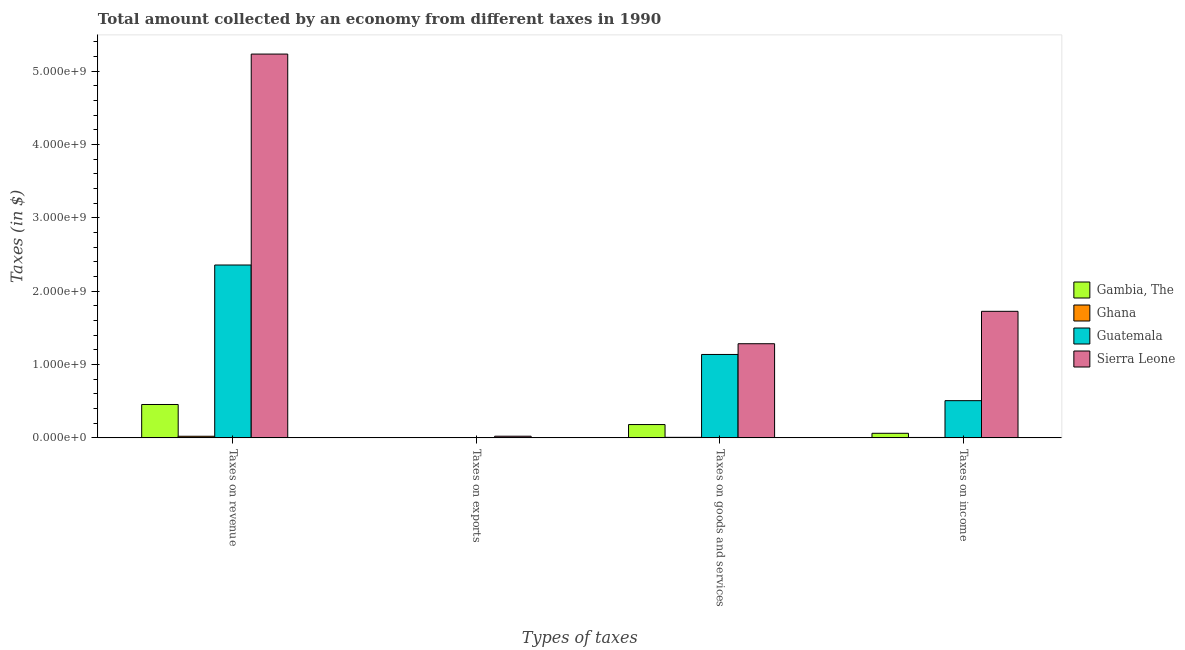How many different coloured bars are there?
Make the answer very short. 4. Are the number of bars per tick equal to the number of legend labels?
Your answer should be compact. Yes. How many bars are there on the 4th tick from the left?
Provide a succinct answer. 4. How many bars are there on the 1st tick from the right?
Offer a very short reply. 4. What is the label of the 3rd group of bars from the left?
Your answer should be very brief. Taxes on goods and services. What is the amount collected as tax on goods in Gambia, The?
Provide a succinct answer. 1.81e+08. Across all countries, what is the maximum amount collected as tax on revenue?
Provide a short and direct response. 5.23e+09. Across all countries, what is the minimum amount collected as tax on goods?
Offer a very short reply. 7.17e+06. In which country was the amount collected as tax on revenue maximum?
Offer a terse response. Sierra Leone. What is the total amount collected as tax on revenue in the graph?
Ensure brevity in your answer.  8.06e+09. What is the difference between the amount collected as tax on income in Sierra Leone and that in Guatemala?
Your response must be concise. 1.22e+09. What is the difference between the amount collected as tax on goods in Sierra Leone and the amount collected as tax on exports in Ghana?
Give a very brief answer. 1.28e+09. What is the average amount collected as tax on income per country?
Offer a terse response. 5.75e+08. What is the difference between the amount collected as tax on revenue and amount collected as tax on goods in Gambia, The?
Ensure brevity in your answer.  2.73e+08. What is the ratio of the amount collected as tax on goods in Sierra Leone to that in Ghana?
Keep it short and to the point. 178.92. Is the difference between the amount collected as tax on exports in Sierra Leone and Gambia, The greater than the difference between the amount collected as tax on goods in Sierra Leone and Gambia, The?
Provide a short and direct response. No. What is the difference between the highest and the second highest amount collected as tax on revenue?
Provide a succinct answer. 2.88e+09. What is the difference between the highest and the lowest amount collected as tax on income?
Your answer should be very brief. 1.72e+09. In how many countries, is the amount collected as tax on revenue greater than the average amount collected as tax on revenue taken over all countries?
Ensure brevity in your answer.  2. What does the 4th bar from the left in Taxes on exports represents?
Give a very brief answer. Sierra Leone. What does the 4th bar from the right in Taxes on revenue represents?
Keep it short and to the point. Gambia, The. How many bars are there?
Your answer should be compact. 16. Does the graph contain grids?
Offer a terse response. No. Where does the legend appear in the graph?
Your response must be concise. Center right. How are the legend labels stacked?
Provide a short and direct response. Vertical. What is the title of the graph?
Offer a terse response. Total amount collected by an economy from different taxes in 1990. Does "Azerbaijan" appear as one of the legend labels in the graph?
Provide a succinct answer. No. What is the label or title of the X-axis?
Give a very brief answer. Types of taxes. What is the label or title of the Y-axis?
Offer a terse response. Taxes (in $). What is the Taxes (in $) in Gambia, The in Taxes on revenue?
Your response must be concise. 4.55e+08. What is the Taxes (in $) of Ghana in Taxes on revenue?
Provide a succinct answer. 2.20e+07. What is the Taxes (in $) of Guatemala in Taxes on revenue?
Make the answer very short. 2.36e+09. What is the Taxes (in $) of Sierra Leone in Taxes on revenue?
Your response must be concise. 5.23e+09. What is the Taxes (in $) of Gambia, The in Taxes on exports?
Offer a very short reply. 9.00e+05. What is the Taxes (in $) in Ghana in Taxes on exports?
Offer a very short reply. 2.72e+06. What is the Taxes (in $) of Guatemala in Taxes on exports?
Offer a terse response. 4.63e+06. What is the Taxes (in $) in Sierra Leone in Taxes on exports?
Your answer should be very brief. 2.27e+07. What is the Taxes (in $) in Gambia, The in Taxes on goods and services?
Make the answer very short. 1.81e+08. What is the Taxes (in $) in Ghana in Taxes on goods and services?
Ensure brevity in your answer.  7.17e+06. What is the Taxes (in $) in Guatemala in Taxes on goods and services?
Make the answer very short. 1.14e+09. What is the Taxes (in $) in Sierra Leone in Taxes on goods and services?
Provide a short and direct response. 1.28e+09. What is the Taxes (in $) of Gambia, The in Taxes on income?
Provide a short and direct response. 6.24e+07. What is the Taxes (in $) in Ghana in Taxes on income?
Make the answer very short. 5.51e+06. What is the Taxes (in $) of Guatemala in Taxes on income?
Offer a terse response. 5.07e+08. What is the Taxes (in $) in Sierra Leone in Taxes on income?
Provide a succinct answer. 1.72e+09. Across all Types of taxes, what is the maximum Taxes (in $) in Gambia, The?
Your response must be concise. 4.55e+08. Across all Types of taxes, what is the maximum Taxes (in $) in Ghana?
Your response must be concise. 2.20e+07. Across all Types of taxes, what is the maximum Taxes (in $) in Guatemala?
Your response must be concise. 2.36e+09. Across all Types of taxes, what is the maximum Taxes (in $) of Sierra Leone?
Ensure brevity in your answer.  5.23e+09. Across all Types of taxes, what is the minimum Taxes (in $) in Gambia, The?
Keep it short and to the point. 9.00e+05. Across all Types of taxes, what is the minimum Taxes (in $) of Ghana?
Offer a very short reply. 2.72e+06. Across all Types of taxes, what is the minimum Taxes (in $) of Guatemala?
Provide a short and direct response. 4.63e+06. Across all Types of taxes, what is the minimum Taxes (in $) in Sierra Leone?
Make the answer very short. 2.27e+07. What is the total Taxes (in $) in Gambia, The in the graph?
Your answer should be very brief. 7.00e+08. What is the total Taxes (in $) in Ghana in the graph?
Offer a very short reply. 3.74e+07. What is the total Taxes (in $) in Guatemala in the graph?
Give a very brief answer. 4.00e+09. What is the total Taxes (in $) in Sierra Leone in the graph?
Your answer should be very brief. 8.26e+09. What is the difference between the Taxes (in $) in Gambia, The in Taxes on revenue and that in Taxes on exports?
Offer a very short reply. 4.54e+08. What is the difference between the Taxes (in $) in Ghana in Taxes on revenue and that in Taxes on exports?
Provide a short and direct response. 1.92e+07. What is the difference between the Taxes (in $) of Guatemala in Taxes on revenue and that in Taxes on exports?
Ensure brevity in your answer.  2.35e+09. What is the difference between the Taxes (in $) in Sierra Leone in Taxes on revenue and that in Taxes on exports?
Your answer should be very brief. 5.21e+09. What is the difference between the Taxes (in $) in Gambia, The in Taxes on revenue and that in Taxes on goods and services?
Your answer should be compact. 2.73e+08. What is the difference between the Taxes (in $) in Ghana in Taxes on revenue and that in Taxes on goods and services?
Give a very brief answer. 1.48e+07. What is the difference between the Taxes (in $) in Guatemala in Taxes on revenue and that in Taxes on goods and services?
Your answer should be compact. 1.22e+09. What is the difference between the Taxes (in $) of Sierra Leone in Taxes on revenue and that in Taxes on goods and services?
Offer a very short reply. 3.95e+09. What is the difference between the Taxes (in $) of Gambia, The in Taxes on revenue and that in Taxes on income?
Your response must be concise. 3.92e+08. What is the difference between the Taxes (in $) in Ghana in Taxes on revenue and that in Taxes on income?
Offer a terse response. 1.65e+07. What is the difference between the Taxes (in $) in Guatemala in Taxes on revenue and that in Taxes on income?
Your answer should be compact. 1.85e+09. What is the difference between the Taxes (in $) in Sierra Leone in Taxes on revenue and that in Taxes on income?
Ensure brevity in your answer.  3.51e+09. What is the difference between the Taxes (in $) in Gambia, The in Taxes on exports and that in Taxes on goods and services?
Provide a short and direct response. -1.81e+08. What is the difference between the Taxes (in $) of Ghana in Taxes on exports and that in Taxes on goods and services?
Make the answer very short. -4.45e+06. What is the difference between the Taxes (in $) of Guatemala in Taxes on exports and that in Taxes on goods and services?
Provide a short and direct response. -1.13e+09. What is the difference between the Taxes (in $) in Sierra Leone in Taxes on exports and that in Taxes on goods and services?
Ensure brevity in your answer.  -1.26e+09. What is the difference between the Taxes (in $) in Gambia, The in Taxes on exports and that in Taxes on income?
Ensure brevity in your answer.  -6.15e+07. What is the difference between the Taxes (in $) of Ghana in Taxes on exports and that in Taxes on income?
Provide a succinct answer. -2.80e+06. What is the difference between the Taxes (in $) of Guatemala in Taxes on exports and that in Taxes on income?
Keep it short and to the point. -5.02e+08. What is the difference between the Taxes (in $) in Sierra Leone in Taxes on exports and that in Taxes on income?
Ensure brevity in your answer.  -1.70e+09. What is the difference between the Taxes (in $) in Gambia, The in Taxes on goods and services and that in Taxes on income?
Make the answer very short. 1.19e+08. What is the difference between the Taxes (in $) in Ghana in Taxes on goods and services and that in Taxes on income?
Keep it short and to the point. 1.66e+06. What is the difference between the Taxes (in $) of Guatemala in Taxes on goods and services and that in Taxes on income?
Ensure brevity in your answer.  6.30e+08. What is the difference between the Taxes (in $) of Sierra Leone in Taxes on goods and services and that in Taxes on income?
Offer a terse response. -4.42e+08. What is the difference between the Taxes (in $) in Gambia, The in Taxes on revenue and the Taxes (in $) in Ghana in Taxes on exports?
Your answer should be compact. 4.52e+08. What is the difference between the Taxes (in $) of Gambia, The in Taxes on revenue and the Taxes (in $) of Guatemala in Taxes on exports?
Keep it short and to the point. 4.50e+08. What is the difference between the Taxes (in $) in Gambia, The in Taxes on revenue and the Taxes (in $) in Sierra Leone in Taxes on exports?
Keep it short and to the point. 4.32e+08. What is the difference between the Taxes (in $) of Ghana in Taxes on revenue and the Taxes (in $) of Guatemala in Taxes on exports?
Provide a succinct answer. 1.73e+07. What is the difference between the Taxes (in $) in Ghana in Taxes on revenue and the Taxes (in $) in Sierra Leone in Taxes on exports?
Your answer should be compact. -7.32e+05. What is the difference between the Taxes (in $) of Guatemala in Taxes on revenue and the Taxes (in $) of Sierra Leone in Taxes on exports?
Provide a succinct answer. 2.33e+09. What is the difference between the Taxes (in $) in Gambia, The in Taxes on revenue and the Taxes (in $) in Ghana in Taxes on goods and services?
Your answer should be very brief. 4.48e+08. What is the difference between the Taxes (in $) in Gambia, The in Taxes on revenue and the Taxes (in $) in Guatemala in Taxes on goods and services?
Your answer should be very brief. -6.82e+08. What is the difference between the Taxes (in $) of Gambia, The in Taxes on revenue and the Taxes (in $) of Sierra Leone in Taxes on goods and services?
Offer a very short reply. -8.28e+08. What is the difference between the Taxes (in $) of Ghana in Taxes on revenue and the Taxes (in $) of Guatemala in Taxes on goods and services?
Give a very brief answer. -1.11e+09. What is the difference between the Taxes (in $) in Ghana in Taxes on revenue and the Taxes (in $) in Sierra Leone in Taxes on goods and services?
Give a very brief answer. -1.26e+09. What is the difference between the Taxes (in $) in Guatemala in Taxes on revenue and the Taxes (in $) in Sierra Leone in Taxes on goods and services?
Your response must be concise. 1.07e+09. What is the difference between the Taxes (in $) in Gambia, The in Taxes on revenue and the Taxes (in $) in Ghana in Taxes on income?
Give a very brief answer. 4.49e+08. What is the difference between the Taxes (in $) of Gambia, The in Taxes on revenue and the Taxes (in $) of Guatemala in Taxes on income?
Your response must be concise. -5.22e+07. What is the difference between the Taxes (in $) of Gambia, The in Taxes on revenue and the Taxes (in $) of Sierra Leone in Taxes on income?
Give a very brief answer. -1.27e+09. What is the difference between the Taxes (in $) in Ghana in Taxes on revenue and the Taxes (in $) in Guatemala in Taxes on income?
Your answer should be compact. -4.85e+08. What is the difference between the Taxes (in $) in Ghana in Taxes on revenue and the Taxes (in $) in Sierra Leone in Taxes on income?
Give a very brief answer. -1.70e+09. What is the difference between the Taxes (in $) in Guatemala in Taxes on revenue and the Taxes (in $) in Sierra Leone in Taxes on income?
Keep it short and to the point. 6.31e+08. What is the difference between the Taxes (in $) in Gambia, The in Taxes on exports and the Taxes (in $) in Ghana in Taxes on goods and services?
Your answer should be very brief. -6.27e+06. What is the difference between the Taxes (in $) in Gambia, The in Taxes on exports and the Taxes (in $) in Guatemala in Taxes on goods and services?
Provide a short and direct response. -1.14e+09. What is the difference between the Taxes (in $) in Gambia, The in Taxes on exports and the Taxes (in $) in Sierra Leone in Taxes on goods and services?
Offer a terse response. -1.28e+09. What is the difference between the Taxes (in $) in Ghana in Taxes on exports and the Taxes (in $) in Guatemala in Taxes on goods and services?
Provide a succinct answer. -1.13e+09. What is the difference between the Taxes (in $) of Ghana in Taxes on exports and the Taxes (in $) of Sierra Leone in Taxes on goods and services?
Offer a terse response. -1.28e+09. What is the difference between the Taxes (in $) in Guatemala in Taxes on exports and the Taxes (in $) in Sierra Leone in Taxes on goods and services?
Give a very brief answer. -1.28e+09. What is the difference between the Taxes (in $) in Gambia, The in Taxes on exports and the Taxes (in $) in Ghana in Taxes on income?
Keep it short and to the point. -4.61e+06. What is the difference between the Taxes (in $) of Gambia, The in Taxes on exports and the Taxes (in $) of Guatemala in Taxes on income?
Provide a short and direct response. -5.06e+08. What is the difference between the Taxes (in $) of Gambia, The in Taxes on exports and the Taxes (in $) of Sierra Leone in Taxes on income?
Offer a terse response. -1.72e+09. What is the difference between the Taxes (in $) in Ghana in Taxes on exports and the Taxes (in $) in Guatemala in Taxes on income?
Make the answer very short. -5.04e+08. What is the difference between the Taxes (in $) in Ghana in Taxes on exports and the Taxes (in $) in Sierra Leone in Taxes on income?
Your response must be concise. -1.72e+09. What is the difference between the Taxes (in $) in Guatemala in Taxes on exports and the Taxes (in $) in Sierra Leone in Taxes on income?
Make the answer very short. -1.72e+09. What is the difference between the Taxes (in $) in Gambia, The in Taxes on goods and services and the Taxes (in $) in Ghana in Taxes on income?
Keep it short and to the point. 1.76e+08. What is the difference between the Taxes (in $) in Gambia, The in Taxes on goods and services and the Taxes (in $) in Guatemala in Taxes on income?
Offer a terse response. -3.26e+08. What is the difference between the Taxes (in $) of Gambia, The in Taxes on goods and services and the Taxes (in $) of Sierra Leone in Taxes on income?
Give a very brief answer. -1.54e+09. What is the difference between the Taxes (in $) in Ghana in Taxes on goods and services and the Taxes (in $) in Guatemala in Taxes on income?
Your answer should be very brief. -5.00e+08. What is the difference between the Taxes (in $) in Ghana in Taxes on goods and services and the Taxes (in $) in Sierra Leone in Taxes on income?
Offer a very short reply. -1.72e+09. What is the difference between the Taxes (in $) in Guatemala in Taxes on goods and services and the Taxes (in $) in Sierra Leone in Taxes on income?
Provide a short and direct response. -5.88e+08. What is the average Taxes (in $) of Gambia, The per Types of taxes?
Your answer should be compact. 1.75e+08. What is the average Taxes (in $) of Ghana per Types of taxes?
Keep it short and to the point. 9.34e+06. What is the average Taxes (in $) of Guatemala per Types of taxes?
Provide a short and direct response. 1.00e+09. What is the average Taxes (in $) in Sierra Leone per Types of taxes?
Make the answer very short. 2.07e+09. What is the difference between the Taxes (in $) of Gambia, The and Taxes (in $) of Ghana in Taxes on revenue?
Your response must be concise. 4.33e+08. What is the difference between the Taxes (in $) in Gambia, The and Taxes (in $) in Guatemala in Taxes on revenue?
Offer a very short reply. -1.90e+09. What is the difference between the Taxes (in $) of Gambia, The and Taxes (in $) of Sierra Leone in Taxes on revenue?
Give a very brief answer. -4.78e+09. What is the difference between the Taxes (in $) of Ghana and Taxes (in $) of Guatemala in Taxes on revenue?
Your response must be concise. -2.33e+09. What is the difference between the Taxes (in $) of Ghana and Taxes (in $) of Sierra Leone in Taxes on revenue?
Keep it short and to the point. -5.21e+09. What is the difference between the Taxes (in $) in Guatemala and Taxes (in $) in Sierra Leone in Taxes on revenue?
Your response must be concise. -2.88e+09. What is the difference between the Taxes (in $) in Gambia, The and Taxes (in $) in Ghana in Taxes on exports?
Offer a terse response. -1.82e+06. What is the difference between the Taxes (in $) in Gambia, The and Taxes (in $) in Guatemala in Taxes on exports?
Give a very brief answer. -3.73e+06. What is the difference between the Taxes (in $) of Gambia, The and Taxes (in $) of Sierra Leone in Taxes on exports?
Ensure brevity in your answer.  -2.18e+07. What is the difference between the Taxes (in $) in Ghana and Taxes (in $) in Guatemala in Taxes on exports?
Keep it short and to the point. -1.91e+06. What is the difference between the Taxes (in $) of Ghana and Taxes (in $) of Sierra Leone in Taxes on exports?
Make the answer very short. -2.00e+07. What is the difference between the Taxes (in $) of Guatemala and Taxes (in $) of Sierra Leone in Taxes on exports?
Your answer should be compact. -1.81e+07. What is the difference between the Taxes (in $) in Gambia, The and Taxes (in $) in Ghana in Taxes on goods and services?
Your answer should be compact. 1.74e+08. What is the difference between the Taxes (in $) of Gambia, The and Taxes (in $) of Guatemala in Taxes on goods and services?
Your response must be concise. -9.55e+08. What is the difference between the Taxes (in $) of Gambia, The and Taxes (in $) of Sierra Leone in Taxes on goods and services?
Offer a very short reply. -1.10e+09. What is the difference between the Taxes (in $) of Ghana and Taxes (in $) of Guatemala in Taxes on goods and services?
Make the answer very short. -1.13e+09. What is the difference between the Taxes (in $) in Ghana and Taxes (in $) in Sierra Leone in Taxes on goods and services?
Make the answer very short. -1.28e+09. What is the difference between the Taxes (in $) of Guatemala and Taxes (in $) of Sierra Leone in Taxes on goods and services?
Offer a terse response. -1.46e+08. What is the difference between the Taxes (in $) in Gambia, The and Taxes (in $) in Ghana in Taxes on income?
Make the answer very short. 5.69e+07. What is the difference between the Taxes (in $) of Gambia, The and Taxes (in $) of Guatemala in Taxes on income?
Give a very brief answer. -4.45e+08. What is the difference between the Taxes (in $) in Gambia, The and Taxes (in $) in Sierra Leone in Taxes on income?
Give a very brief answer. -1.66e+09. What is the difference between the Taxes (in $) in Ghana and Taxes (in $) in Guatemala in Taxes on income?
Your answer should be very brief. -5.01e+08. What is the difference between the Taxes (in $) of Ghana and Taxes (in $) of Sierra Leone in Taxes on income?
Your answer should be very brief. -1.72e+09. What is the difference between the Taxes (in $) of Guatemala and Taxes (in $) of Sierra Leone in Taxes on income?
Ensure brevity in your answer.  -1.22e+09. What is the ratio of the Taxes (in $) in Gambia, The in Taxes on revenue to that in Taxes on exports?
Your answer should be very brief. 505.34. What is the ratio of the Taxes (in $) of Ghana in Taxes on revenue to that in Taxes on exports?
Provide a succinct answer. 8.08. What is the ratio of the Taxes (in $) in Guatemala in Taxes on revenue to that in Taxes on exports?
Make the answer very short. 508.84. What is the ratio of the Taxes (in $) in Sierra Leone in Taxes on revenue to that in Taxes on exports?
Your answer should be compact. 230.44. What is the ratio of the Taxes (in $) of Gambia, The in Taxes on revenue to that in Taxes on goods and services?
Ensure brevity in your answer.  2.51. What is the ratio of the Taxes (in $) in Ghana in Taxes on revenue to that in Taxes on goods and services?
Your answer should be very brief. 3.06. What is the ratio of the Taxes (in $) of Guatemala in Taxes on revenue to that in Taxes on goods and services?
Ensure brevity in your answer.  2.07. What is the ratio of the Taxes (in $) in Sierra Leone in Taxes on revenue to that in Taxes on goods and services?
Your answer should be compact. 4.08. What is the ratio of the Taxes (in $) of Gambia, The in Taxes on revenue to that in Taxes on income?
Offer a very short reply. 7.29. What is the ratio of the Taxes (in $) of Ghana in Taxes on revenue to that in Taxes on income?
Your answer should be very brief. 3.98. What is the ratio of the Taxes (in $) of Guatemala in Taxes on revenue to that in Taxes on income?
Your answer should be compact. 4.65. What is the ratio of the Taxes (in $) of Sierra Leone in Taxes on revenue to that in Taxes on income?
Keep it short and to the point. 3.03. What is the ratio of the Taxes (in $) of Gambia, The in Taxes on exports to that in Taxes on goods and services?
Provide a succinct answer. 0.01. What is the ratio of the Taxes (in $) of Ghana in Taxes on exports to that in Taxes on goods and services?
Your answer should be very brief. 0.38. What is the ratio of the Taxes (in $) of Guatemala in Taxes on exports to that in Taxes on goods and services?
Your answer should be very brief. 0. What is the ratio of the Taxes (in $) of Sierra Leone in Taxes on exports to that in Taxes on goods and services?
Your answer should be very brief. 0.02. What is the ratio of the Taxes (in $) in Gambia, The in Taxes on exports to that in Taxes on income?
Keep it short and to the point. 0.01. What is the ratio of the Taxes (in $) of Ghana in Taxes on exports to that in Taxes on income?
Your response must be concise. 0.49. What is the ratio of the Taxes (in $) of Guatemala in Taxes on exports to that in Taxes on income?
Offer a terse response. 0.01. What is the ratio of the Taxes (in $) in Sierra Leone in Taxes on exports to that in Taxes on income?
Make the answer very short. 0.01. What is the ratio of the Taxes (in $) of Gambia, The in Taxes on goods and services to that in Taxes on income?
Your answer should be compact. 2.91. What is the ratio of the Taxes (in $) in Ghana in Taxes on goods and services to that in Taxes on income?
Ensure brevity in your answer.  1.3. What is the ratio of the Taxes (in $) in Guatemala in Taxes on goods and services to that in Taxes on income?
Provide a short and direct response. 2.24. What is the ratio of the Taxes (in $) of Sierra Leone in Taxes on goods and services to that in Taxes on income?
Make the answer very short. 0.74. What is the difference between the highest and the second highest Taxes (in $) in Gambia, The?
Ensure brevity in your answer.  2.73e+08. What is the difference between the highest and the second highest Taxes (in $) in Ghana?
Your response must be concise. 1.48e+07. What is the difference between the highest and the second highest Taxes (in $) of Guatemala?
Give a very brief answer. 1.22e+09. What is the difference between the highest and the second highest Taxes (in $) of Sierra Leone?
Your response must be concise. 3.51e+09. What is the difference between the highest and the lowest Taxes (in $) in Gambia, The?
Your answer should be very brief. 4.54e+08. What is the difference between the highest and the lowest Taxes (in $) in Ghana?
Make the answer very short. 1.92e+07. What is the difference between the highest and the lowest Taxes (in $) of Guatemala?
Provide a succinct answer. 2.35e+09. What is the difference between the highest and the lowest Taxes (in $) in Sierra Leone?
Offer a very short reply. 5.21e+09. 